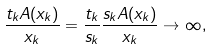Convert formula to latex. <formula><loc_0><loc_0><loc_500><loc_500>\frac { t _ { k } A ( x _ { k } ) } { x _ { k } } = \frac { t _ { k } } { s _ { k } } \frac { s _ { k } A ( x _ { k } ) } { x _ { k } } \to \infty ,</formula> 